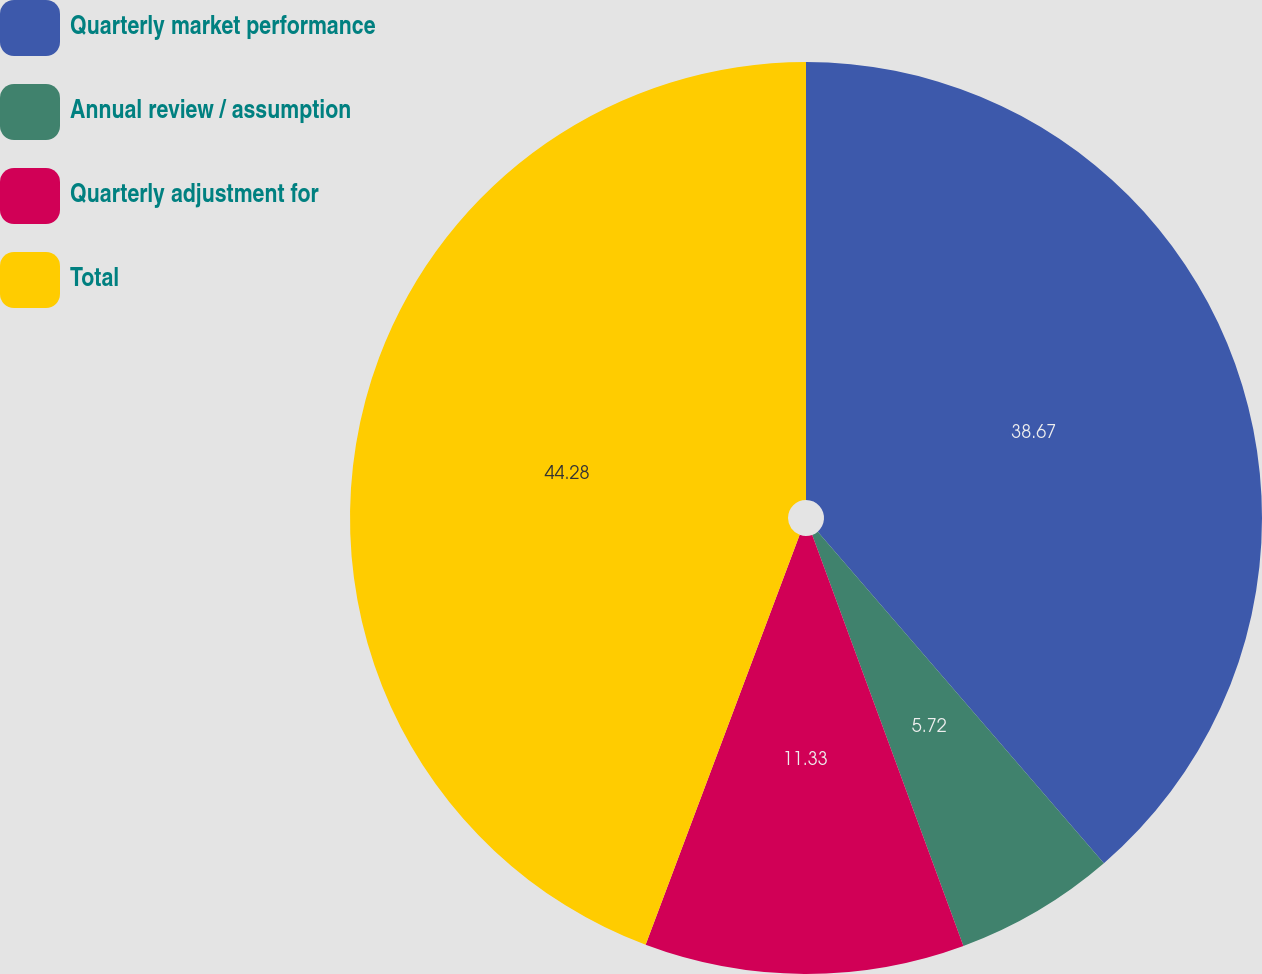Convert chart. <chart><loc_0><loc_0><loc_500><loc_500><pie_chart><fcel>Quarterly market performance<fcel>Annual review / assumption<fcel>Quarterly adjustment for<fcel>Total<nl><fcel>38.67%<fcel>5.72%<fcel>11.33%<fcel>44.28%<nl></chart> 